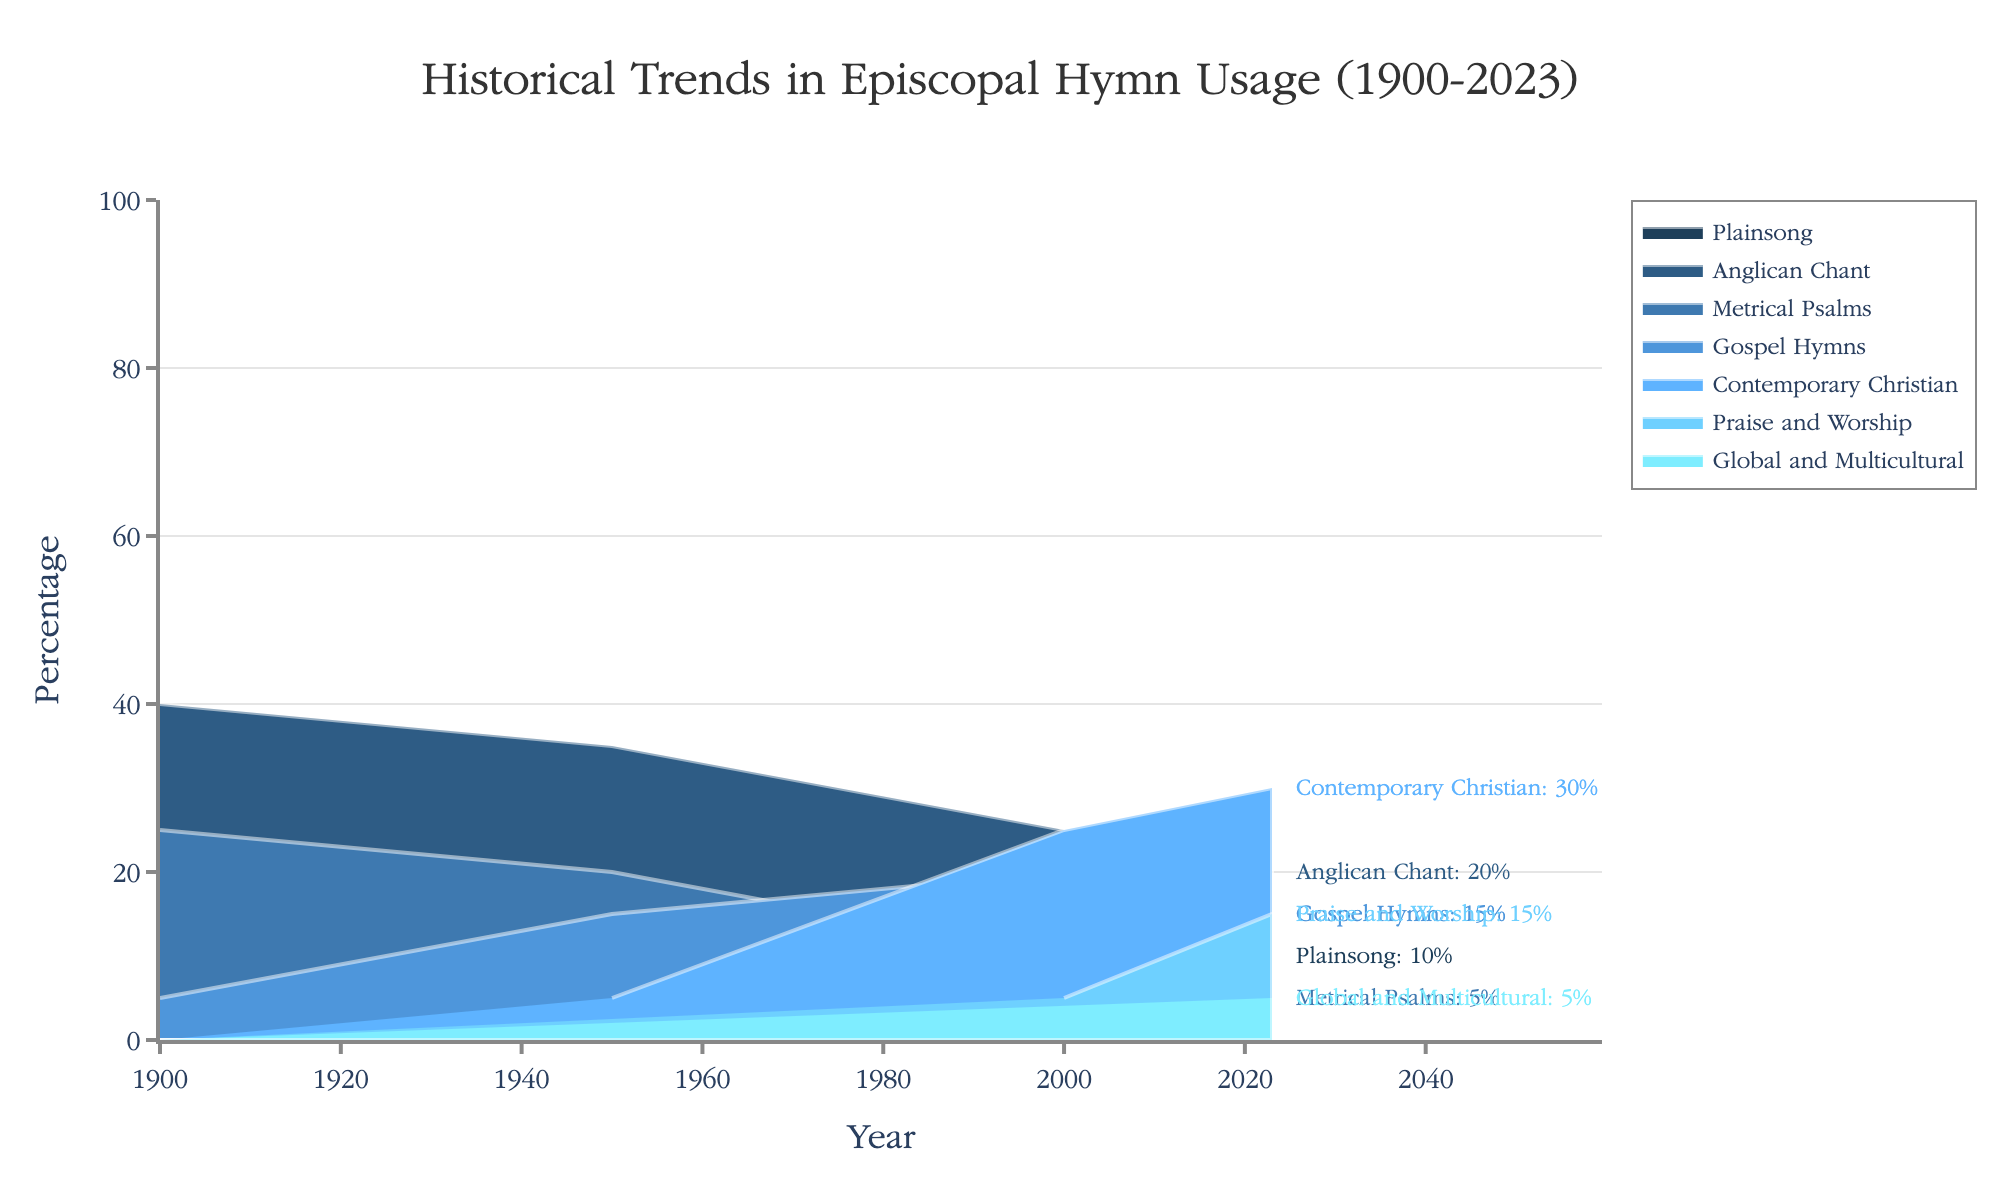What musical style had the highest percentage in 1900? Look at the data for 1900 and identify the style with the highest percentage.
Answer: Anglican Chant How did the percentage of Plainsong usage change from 1900 to 2023? Compare the percentages of Plainsong in 1900 and 2023.
Answer: Decreased from 30% to 10% Which musical style saw the most significant increase in percentage usage from 1900 to 2023? Calculate the percentage change for each style from 1900 to 2023 and identify the one with the highest increase.
Answer: Contemporary Christian What is the total percentage of Traditional hymn styles used in 2000? Sum the percentages of Plainsong, Anglican Chant, and Metrical Psalms for 2000.
Answer: 50% In what year did Gospel Hymns have the highest percentage usage? Identify the year with the highest percentage for Gospel Hymns from the data.
Answer: 2000 How has the usage of Anglican Chant changed from 1950 to 2023? Compare the percentage of Anglican Chant from 1950 to 2023.
Answer: Decreased from 35% to 20% What is the combined percentage of Modern hymn styles in 2023? Sum the percentages of Gospel Hymns, Contemporary Christian, Praise and Worship, and Global and Multicultural for 2023.
Answer: 65% Which musical style had no usage in 1900 but appeared later in the data? Identify the styles not present in 1900 but appear in later years.
Answer: Contemporary Christian, Praise and Worship, Global and Multicultural Which year had the lowest overall percentage of Traditional hymn styles? Calculate and compare the sum of Traditional hymn styles for each year and identify the lowest one.
Answer: 2023 How did the percentage of Gospel Hymns change from 1950 to 2000? Compare the percentages of Gospel Hymns between 1950 and 2000.
Answer: Increased from 15% to 20% 